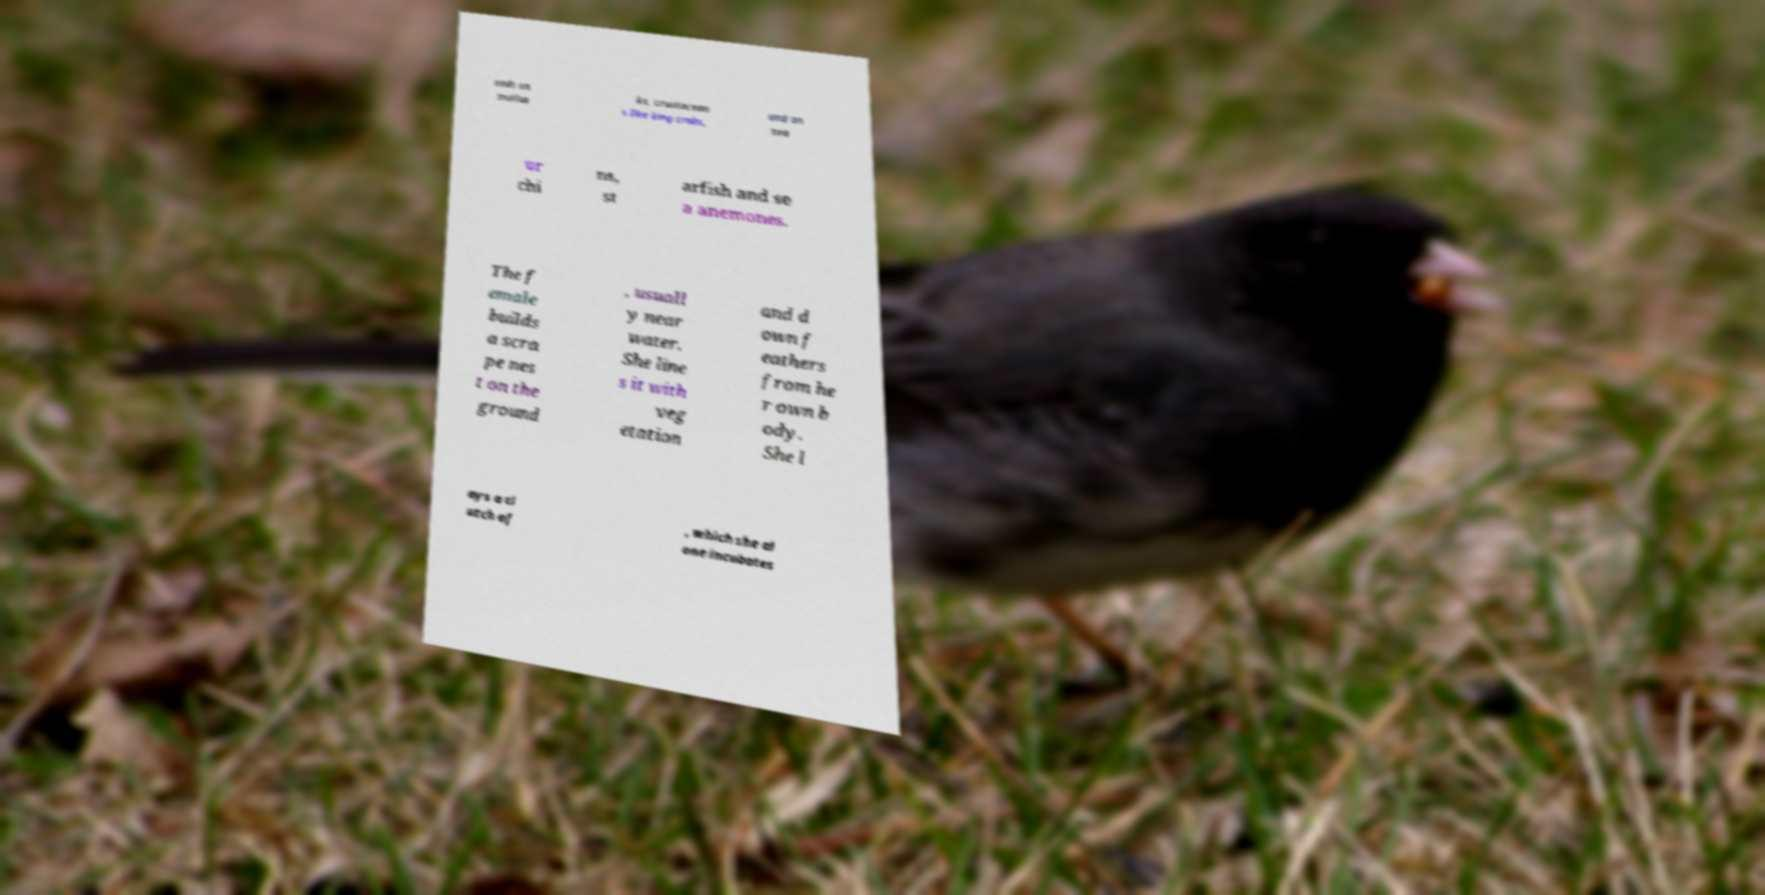Could you extract and type out the text from this image? eeds on mollus ks, crustacean s like king crabs, and on sea ur chi ns, st arfish and se a anemones. The f emale builds a scra pe nes t on the ground , usuall y near water. She line s it with veg etation and d own f eathers from he r own b ody. She l ays a cl utch of , which she al one incubates 